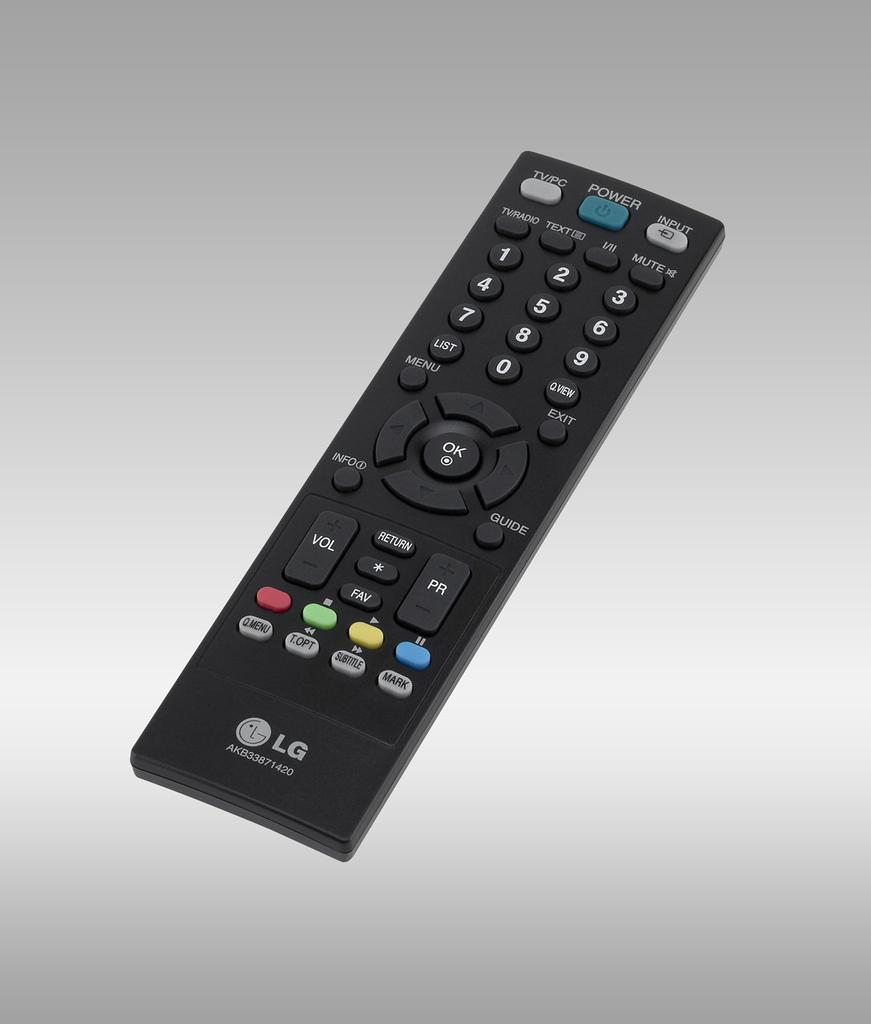<image>
Present a compact description of the photo's key features. a black LG remote control with colorful buttons 